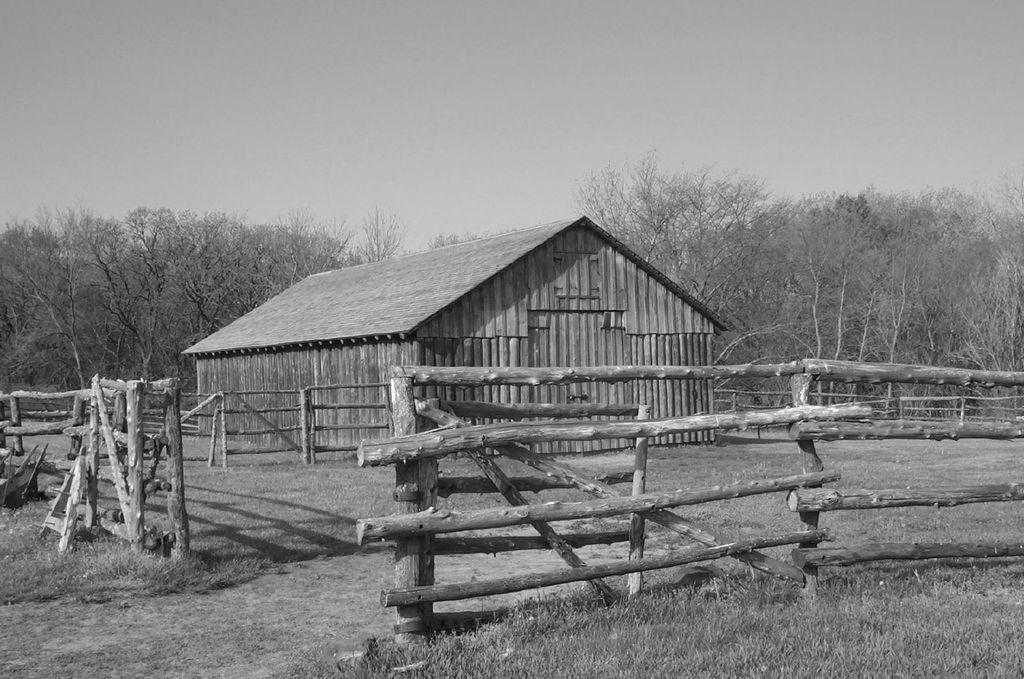What is the color scheme of the image? The image is black and white. What type of house is present in the image? There is a wooden house in the image. What surrounds the wooden house? The wooden house is surrounded by a wooden fence. What type of vegetation can be seen in the image? There is grass in the image. What part of the natural environment is visible in the image? The ground is visible in the image. What else can be seen in the image besides the wooden house and fence? There are trees and the sky visible in the image. How does the image show an increase in the number of rats in the area? The image does not show any rats, nor does it provide any information about the number of rats in the area. 